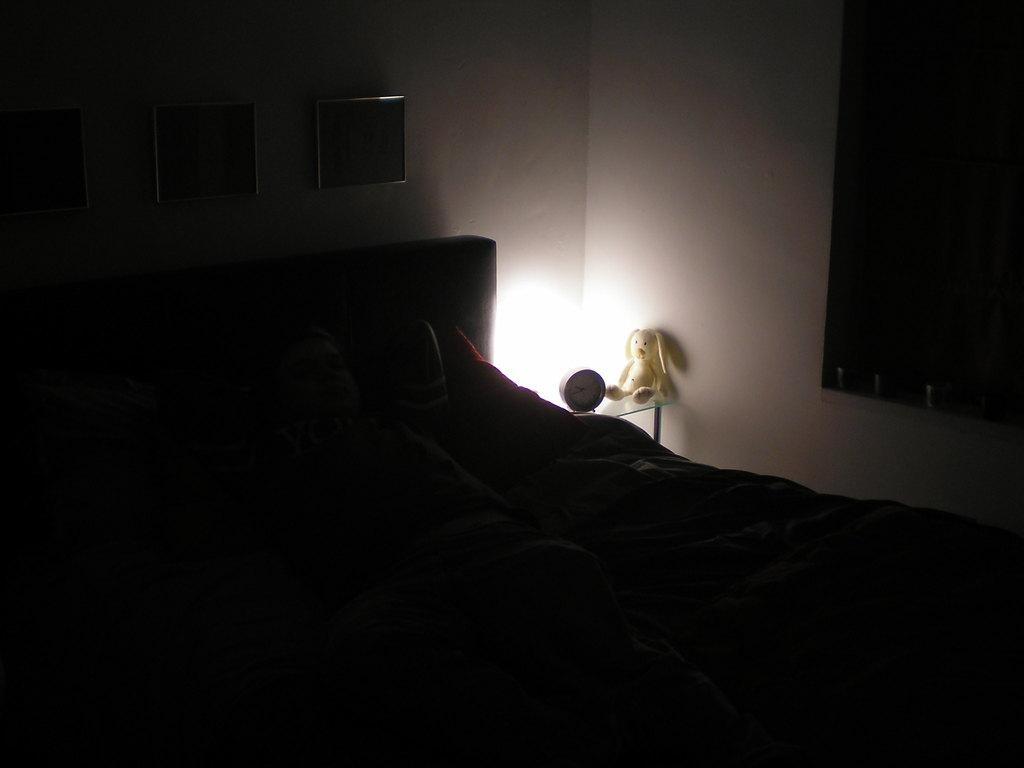What piece of furniture is present in the image? There is a bed in the image. What is placed on the bed? There are pillows on the bed. What can be seen in the image that provides light? There is a light in the image. What type of object is on a table in the image? There is a soft toy on a table. What can be seen on the wall in the background? There are photo frames on a wall in the background. What type of horn can be seen in the image? There is no horn present in the image. Are there any fairies visible in the image? There are no fairies present in the image. 